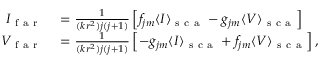<formula> <loc_0><loc_0><loc_500><loc_500>\begin{array} { r l } { I _ { f a r } } & = \frac { 1 } { ( k r ^ { 2 } ) j ( j + 1 ) } \left [ f _ { j m } \langle I \rangle _ { s c a } - g _ { j m } \langle V \rangle _ { s c a } \right ] } \\ { V _ { f a r } } & = \frac { 1 } { ( k r ^ { 2 } ) j ( j + 1 ) } \left [ - g _ { j m } \langle I \rangle _ { s c a } + f _ { j m } \langle V \rangle _ { s c a } \right ] , } \end{array}</formula> 